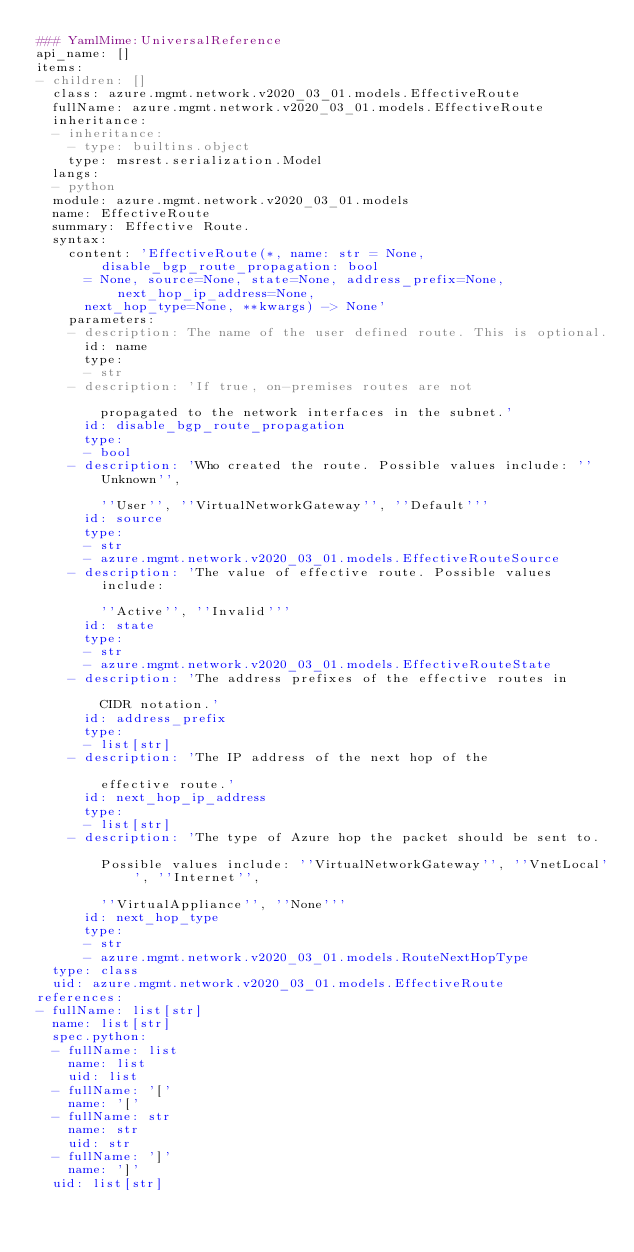<code> <loc_0><loc_0><loc_500><loc_500><_YAML_>### YamlMime:UniversalReference
api_name: []
items:
- children: []
  class: azure.mgmt.network.v2020_03_01.models.EffectiveRoute
  fullName: azure.mgmt.network.v2020_03_01.models.EffectiveRoute
  inheritance:
  - inheritance:
    - type: builtins.object
    type: msrest.serialization.Model
  langs:
  - python
  module: azure.mgmt.network.v2020_03_01.models
  name: EffectiveRoute
  summary: Effective Route.
  syntax:
    content: 'EffectiveRoute(*, name: str = None, disable_bgp_route_propagation: bool
      = None, source=None, state=None, address_prefix=None, next_hop_ip_address=None,
      next_hop_type=None, **kwargs) -> None'
    parameters:
    - description: The name of the user defined route. This is optional.
      id: name
      type:
      - str
    - description: 'If true, on-premises routes are not

        propagated to the network interfaces in the subnet.'
      id: disable_bgp_route_propagation
      type:
      - bool
    - description: 'Who created the route. Possible values include: ''Unknown'',

        ''User'', ''VirtualNetworkGateway'', ''Default'''
      id: source
      type:
      - str
      - azure.mgmt.network.v2020_03_01.models.EffectiveRouteSource
    - description: 'The value of effective route. Possible values include:

        ''Active'', ''Invalid'''
      id: state
      type:
      - str
      - azure.mgmt.network.v2020_03_01.models.EffectiveRouteState
    - description: 'The address prefixes of the effective routes in

        CIDR notation.'
      id: address_prefix
      type:
      - list[str]
    - description: 'The IP address of the next hop of the

        effective route.'
      id: next_hop_ip_address
      type:
      - list[str]
    - description: 'The type of Azure hop the packet should be sent to.

        Possible values include: ''VirtualNetworkGateway'', ''VnetLocal'', ''Internet'',

        ''VirtualAppliance'', ''None'''
      id: next_hop_type
      type:
      - str
      - azure.mgmt.network.v2020_03_01.models.RouteNextHopType
  type: class
  uid: azure.mgmt.network.v2020_03_01.models.EffectiveRoute
references:
- fullName: list[str]
  name: list[str]
  spec.python:
  - fullName: list
    name: list
    uid: list
  - fullName: '['
    name: '['
  - fullName: str
    name: str
    uid: str
  - fullName: ']'
    name: ']'
  uid: list[str]
</code> 